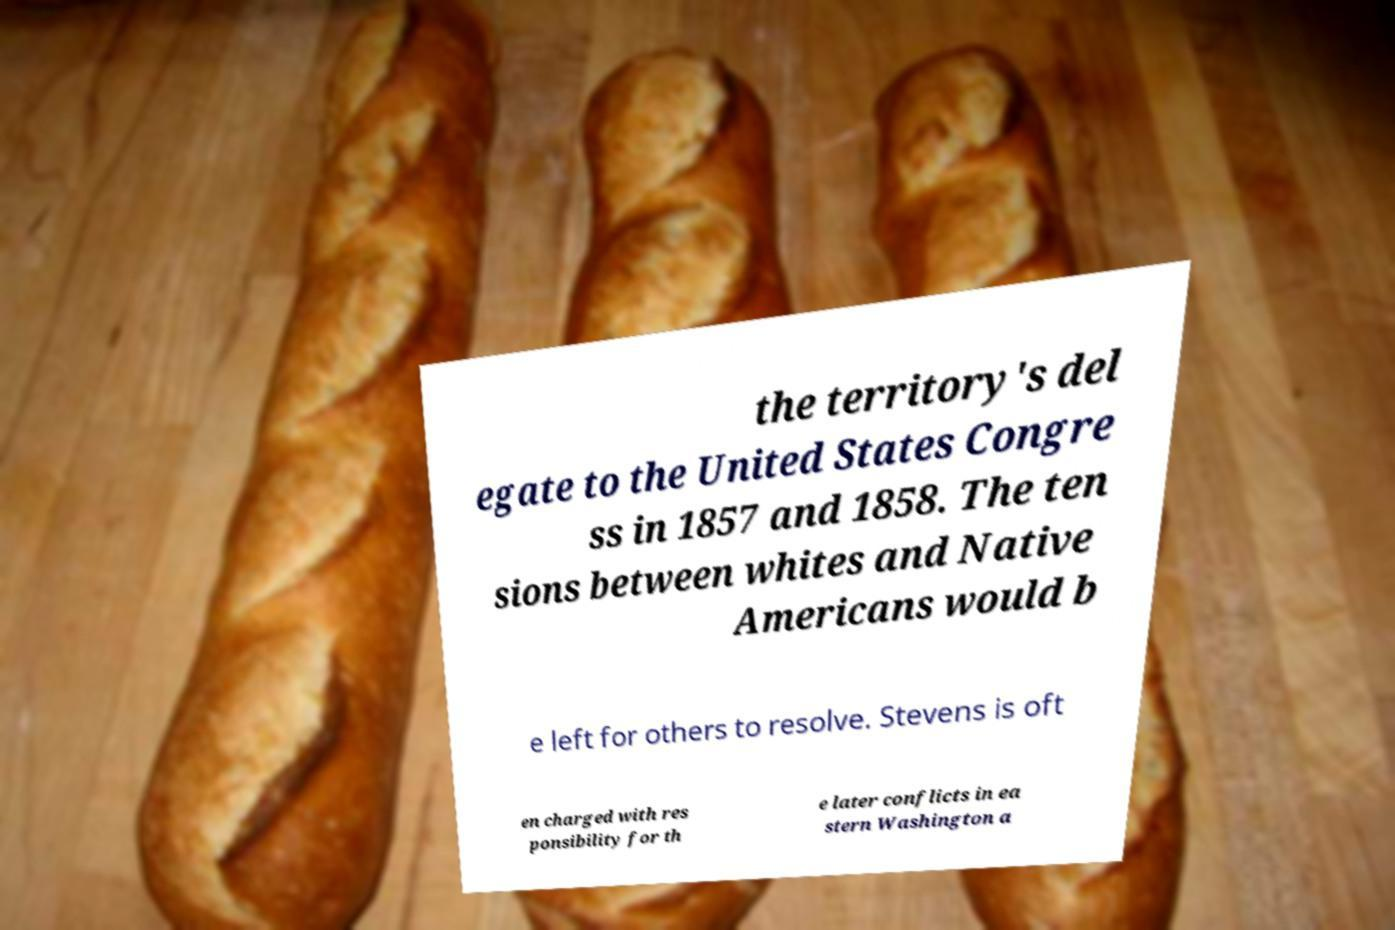Could you assist in decoding the text presented in this image and type it out clearly? the territory's del egate to the United States Congre ss in 1857 and 1858. The ten sions between whites and Native Americans would b e left for others to resolve. Stevens is oft en charged with res ponsibility for th e later conflicts in ea stern Washington a 